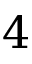Convert formula to latex. <formula><loc_0><loc_0><loc_500><loc_500>4</formula> 